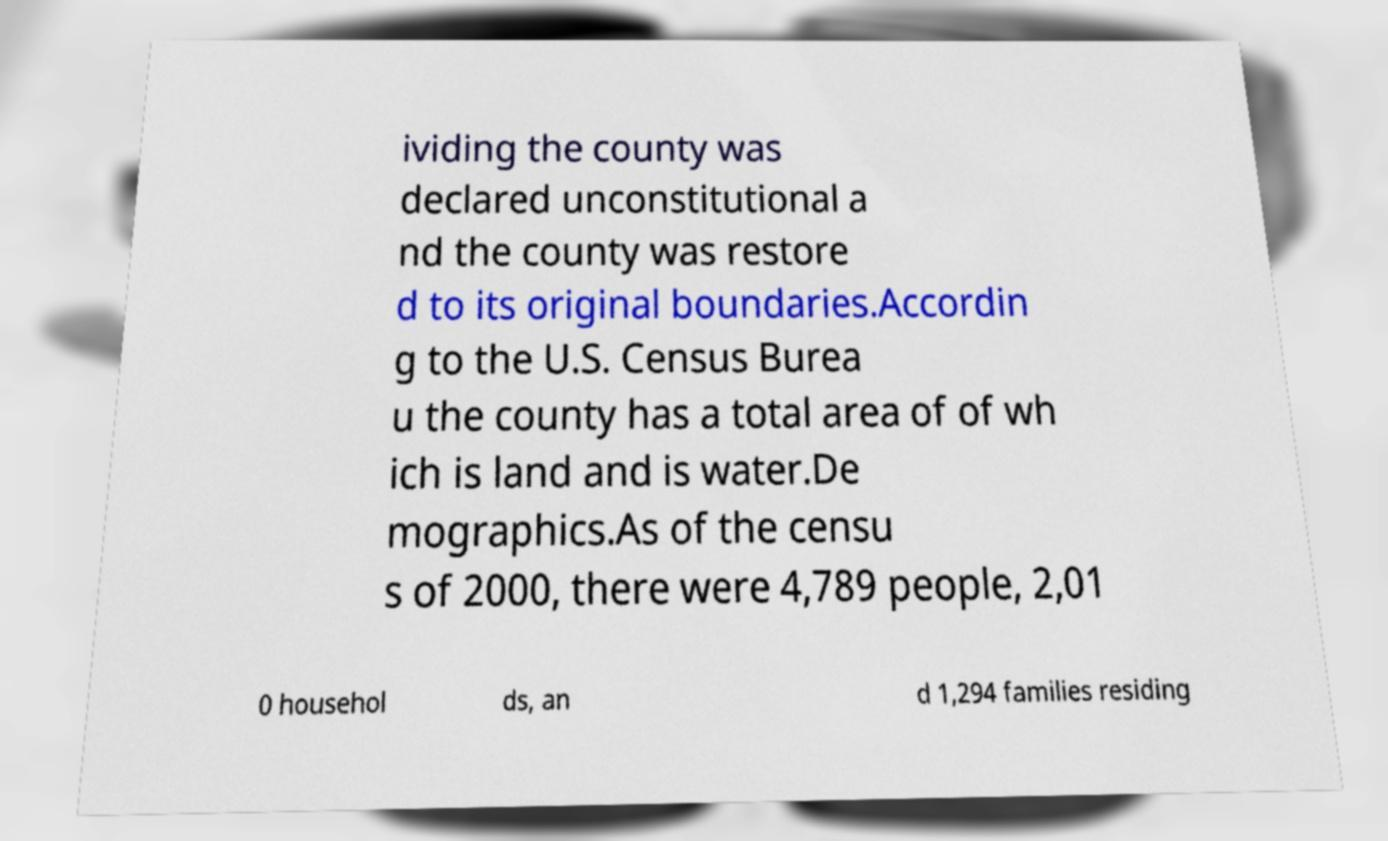Could you assist in decoding the text presented in this image and type it out clearly? ividing the county was declared unconstitutional a nd the county was restore d to its original boundaries.Accordin g to the U.S. Census Burea u the county has a total area of of wh ich is land and is water.De mographics.As of the censu s of 2000, there were 4,789 people, 2,01 0 househol ds, an d 1,294 families residing 